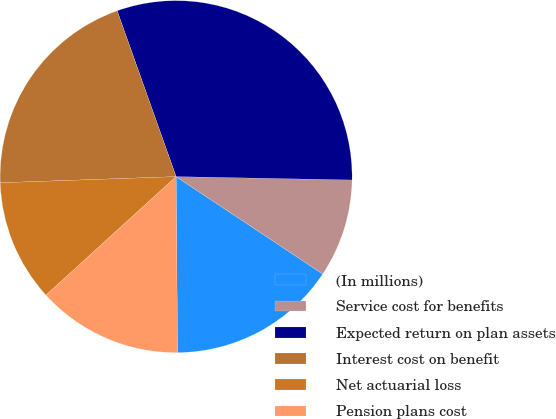Convert chart. <chart><loc_0><loc_0><loc_500><loc_500><pie_chart><fcel>(In millions)<fcel>Service cost for benefits<fcel>Expected return on plan assets<fcel>Interest cost on benefit<fcel>Net actuarial loss<fcel>Pension plans cost<nl><fcel>15.54%<fcel>9.03%<fcel>30.74%<fcel>20.12%<fcel>11.2%<fcel>13.37%<nl></chart> 